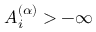<formula> <loc_0><loc_0><loc_500><loc_500>A _ { i } ^ { ( \alpha ) } > - \infty</formula> 